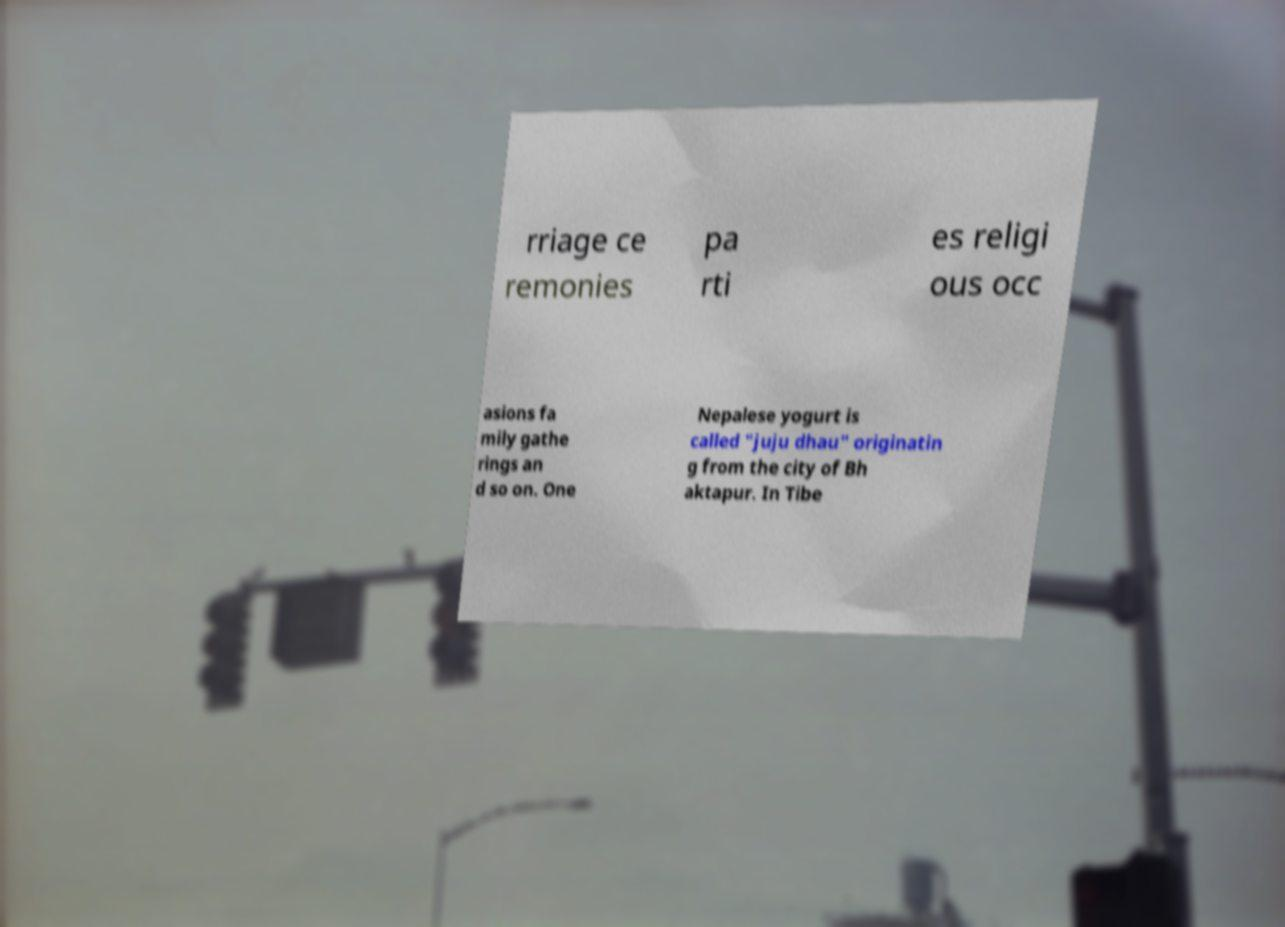Can you read and provide the text displayed in the image?This photo seems to have some interesting text. Can you extract and type it out for me? rriage ce remonies pa rti es religi ous occ asions fa mily gathe rings an d so on. One Nepalese yogurt is called "juju dhau" originatin g from the city of Bh aktapur. In Tibe 